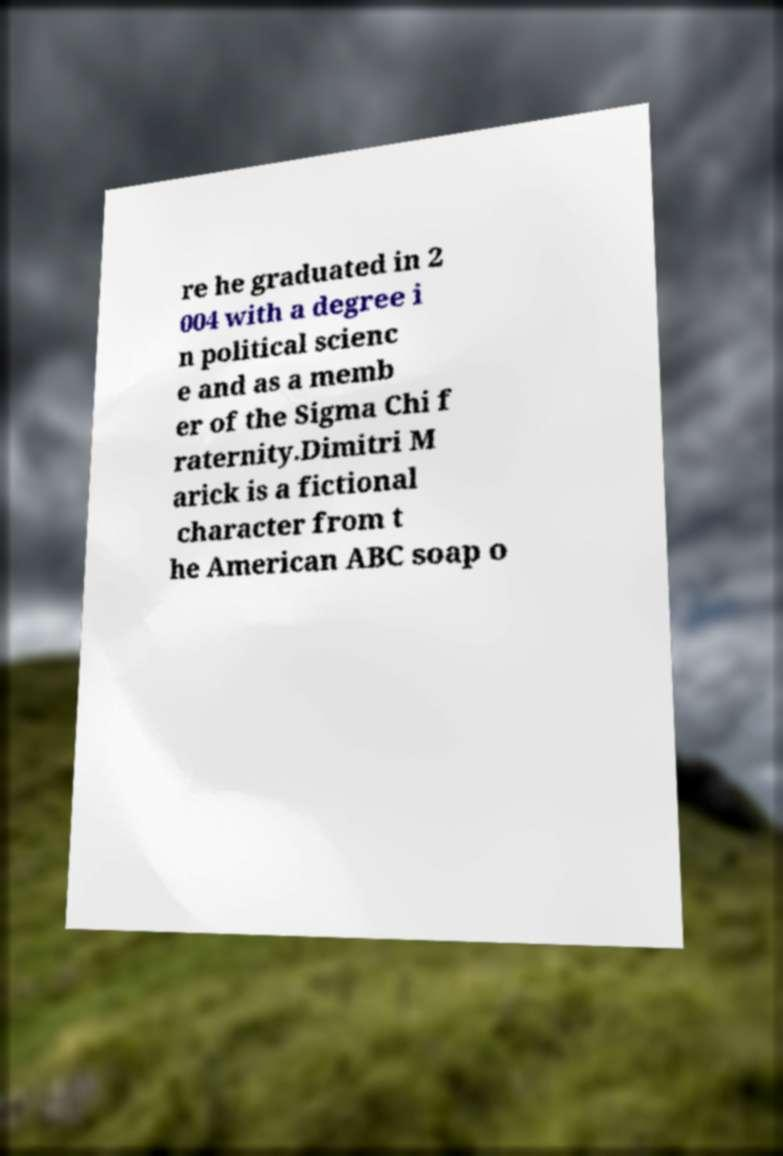What messages or text are displayed in this image? I need them in a readable, typed format. re he graduated in 2 004 with a degree i n political scienc e and as a memb er of the Sigma Chi f raternity.Dimitri M arick is a fictional character from t he American ABC soap o 